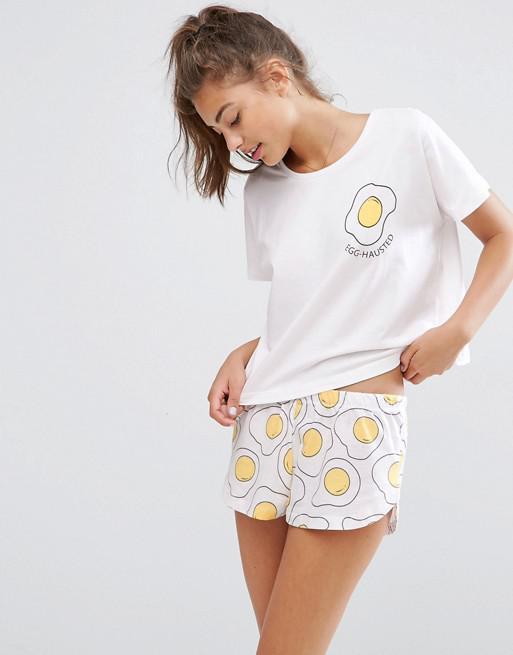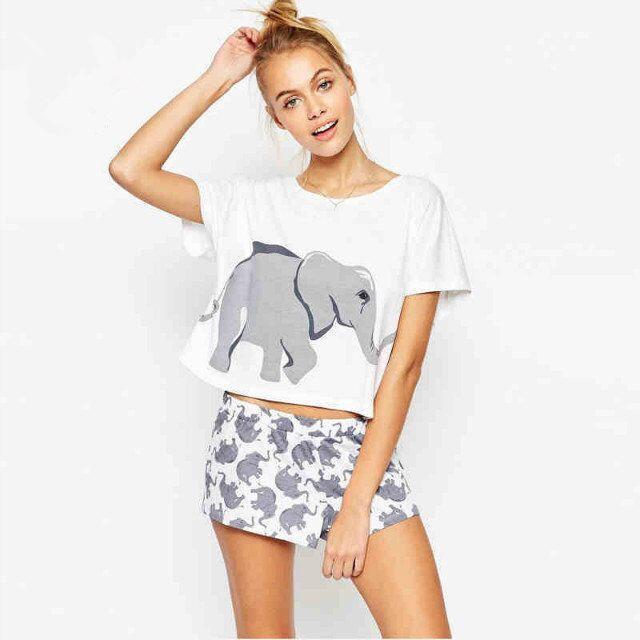The first image is the image on the left, the second image is the image on the right. For the images shown, is this caption "In the images, both models wear bottoms that are virtually the same length." true? Answer yes or no. Yes. 